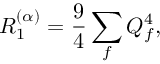Convert formula to latex. <formula><loc_0><loc_0><loc_500><loc_500>R _ { 1 } ^ { ( \alpha ) } = \frac { 9 } { 4 } \sum _ { f } Q _ { f } ^ { 4 } ,</formula> 